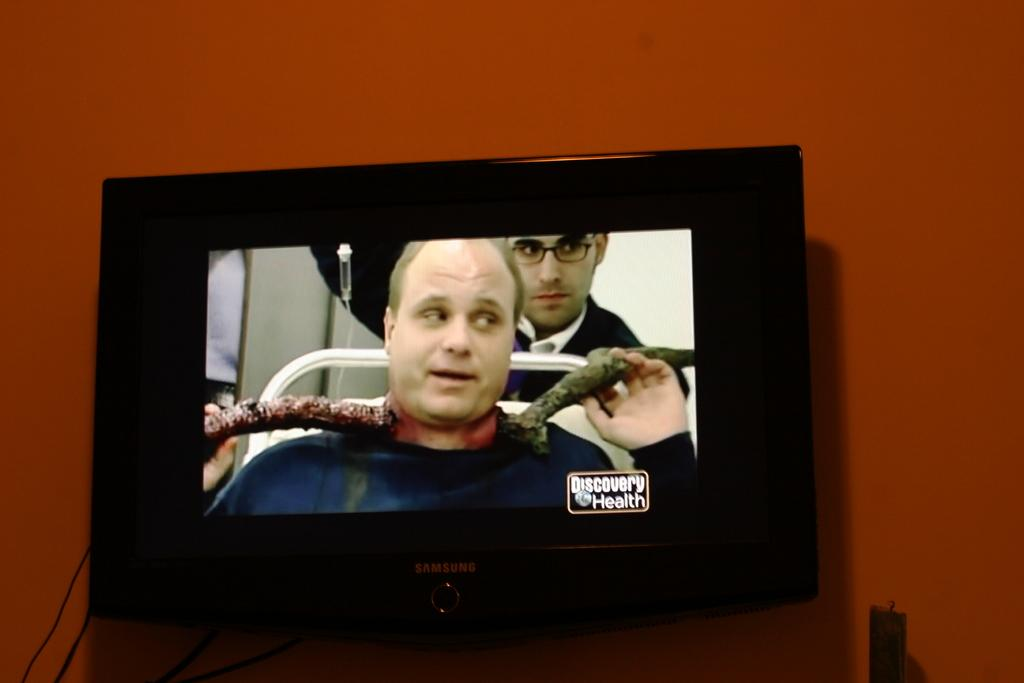<image>
Create a compact narrative representing the image presented. The programme on the tv screen is discovery health. 